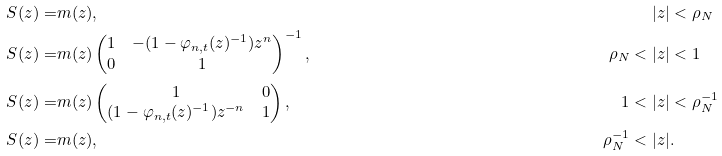<formula> <loc_0><loc_0><loc_500><loc_500>S ( z ) = & m ( z ) , & | z | & < \rho _ { N } \\ S ( z ) = & m ( z ) \begin{pmatrix} 1 & - ( 1 - \varphi _ { n , t } ( z ) ^ { - 1 } ) z ^ { n } \\ 0 & 1 \end{pmatrix} ^ { - 1 } , & \rho _ { N } < | z | & < 1 \\ S ( z ) = & m ( z ) \begin{pmatrix} 1 & 0 \\ ( 1 - \varphi _ { n , t } ( z ) ^ { - 1 } ) z ^ { - n } & 1 \end{pmatrix} , & 1 < | z | & < \rho _ { N } ^ { - 1 } \\ S ( z ) = & m ( z ) , & \rho _ { N } ^ { - 1 } < | z | & .</formula> 